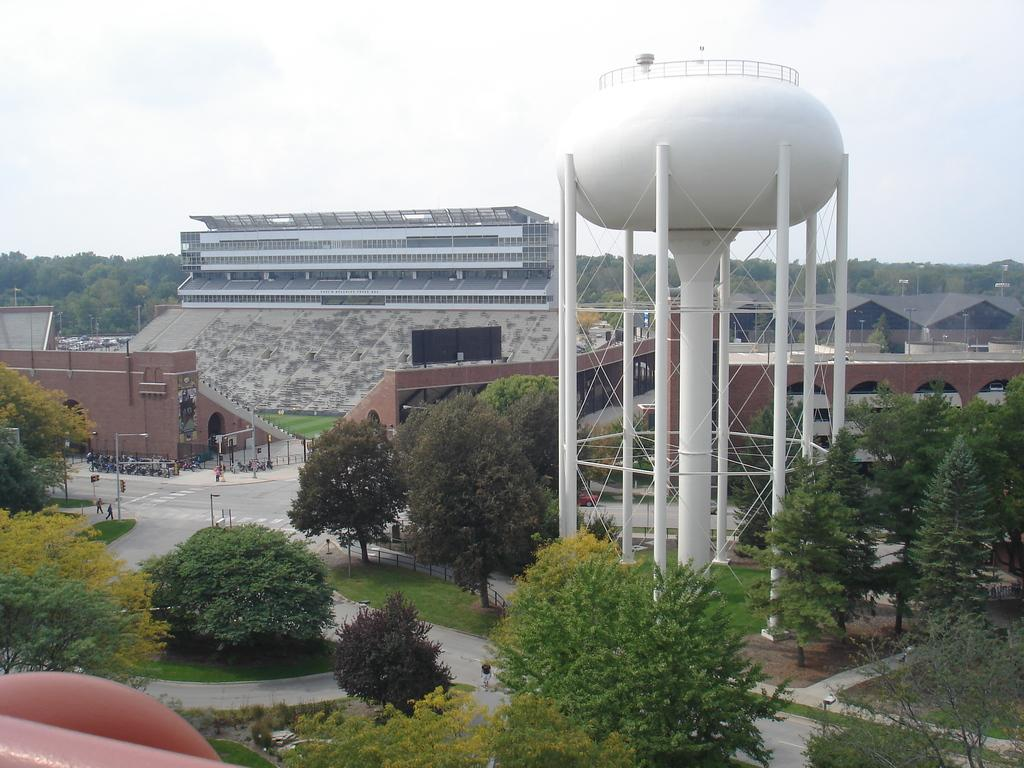What is a part of the natural environment that can be seen in the image? The sky and clouds are part of the natural environment visible in the image. What type of vegetation is present in the image? Trees and plants are present in the image. What type of structures can be seen in the image? Buildings and pillars are visible in the image. Are there any living beings in the image? Yes, there are people standing in the image. What type of sugar is being used to reduce friction between the buildings in the image? There is no sugar or mention of friction in the image; it features the sky, clouds, trees, buildings, pillars, plants, and people. 